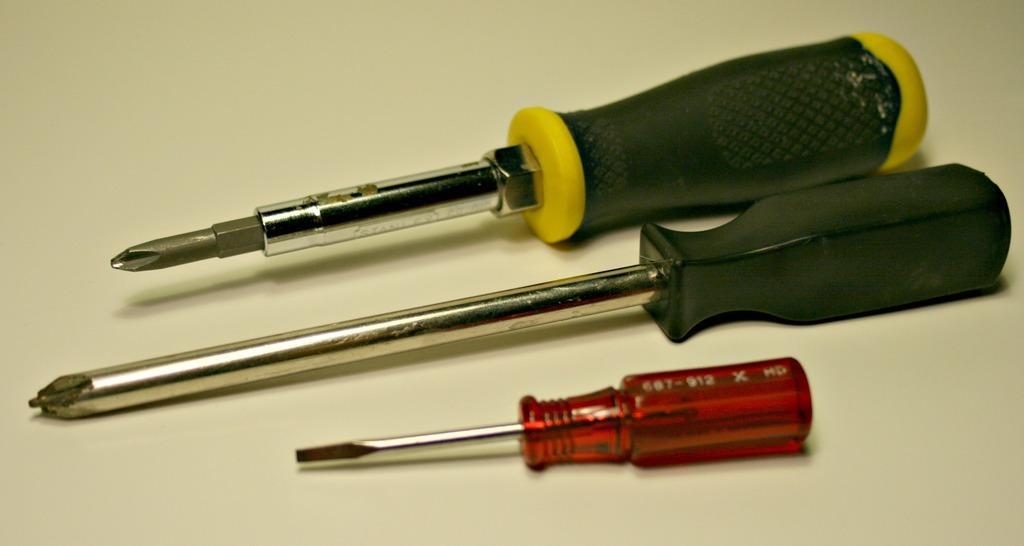Describe this image in one or two sentences. In the foreground of this image, there are three different kind of screw drivers on the surface. 